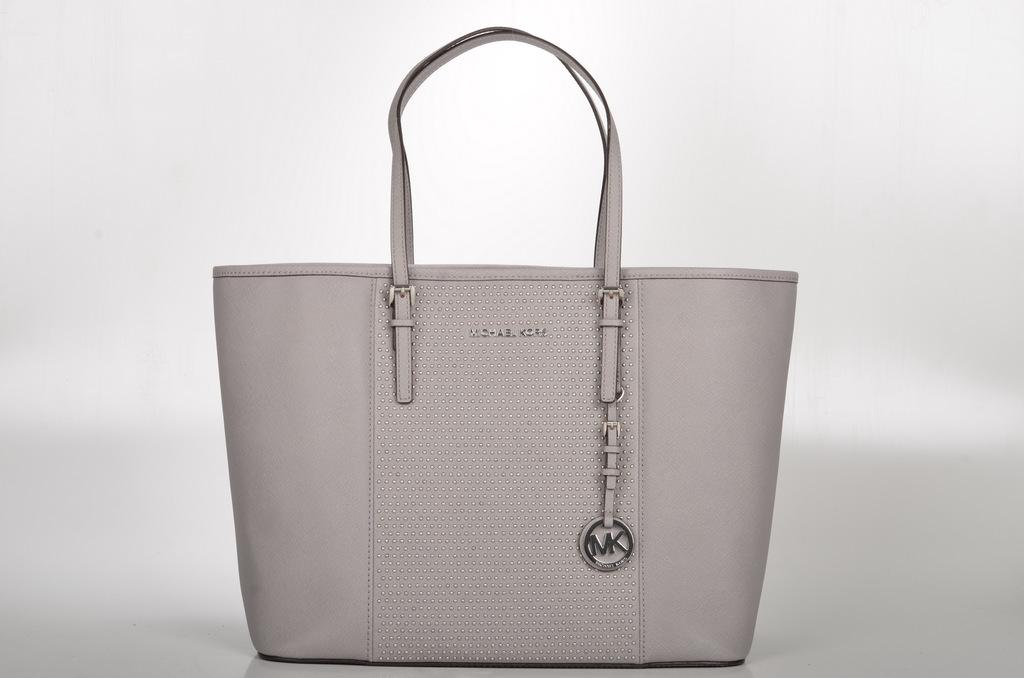What object can be seen in the image? There is a handbag in the image. What color is the handbag? The handbag is ash-colored. Where is the handbag located in the image? The handbag is on the floor. Can you describe the setting of the image? The image is taken inside a room. Where can you buy underwear in the image? There is no store or indication of underwear in the image; it only features a handbag on the floor inside a room. 